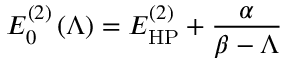Convert formula to latex. <formula><loc_0><loc_0><loc_500><loc_500>E _ { 0 } ^ { ( 2 ) } \left ( \Lambda \right ) = E _ { H P } ^ { ( 2 ) } + \frac { \alpha } { \beta - \Lambda }</formula> 